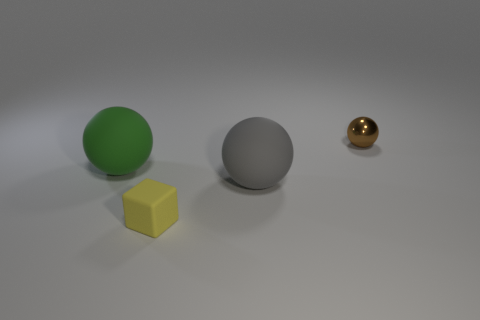There is a matte block; is it the same size as the matte ball right of the green thing?
Offer a very short reply. No. What is the material of the brown thing that is the same shape as the green matte object?
Offer a very short reply. Metal. There is a shiny object that is right of the tiny object in front of the big matte object on the right side of the yellow thing; how big is it?
Ensure brevity in your answer.  Small. Do the metal ball and the green matte sphere have the same size?
Your answer should be very brief. No. There is a small object to the left of the big thing to the right of the tiny matte object; what is its material?
Provide a succinct answer. Rubber. There is a big rubber thing in front of the big green ball; is it the same shape as the small thing on the left side of the tiny brown shiny object?
Offer a terse response. No. Are there the same number of tiny balls left of the small brown metallic sphere and matte things?
Make the answer very short. No. Are there any yellow cubes that are behind the rubber thing that is on the left side of the small yellow matte object?
Give a very brief answer. No. Is there anything else that has the same color as the tiny rubber block?
Your answer should be compact. No. Are the small thing that is behind the big green matte thing and the green object made of the same material?
Provide a short and direct response. No. 